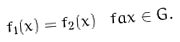Convert formula to latex. <formula><loc_0><loc_0><loc_500><loc_500>f _ { 1 } ( x ) = f _ { 2 } ( x ) \ f a x \in G .</formula> 